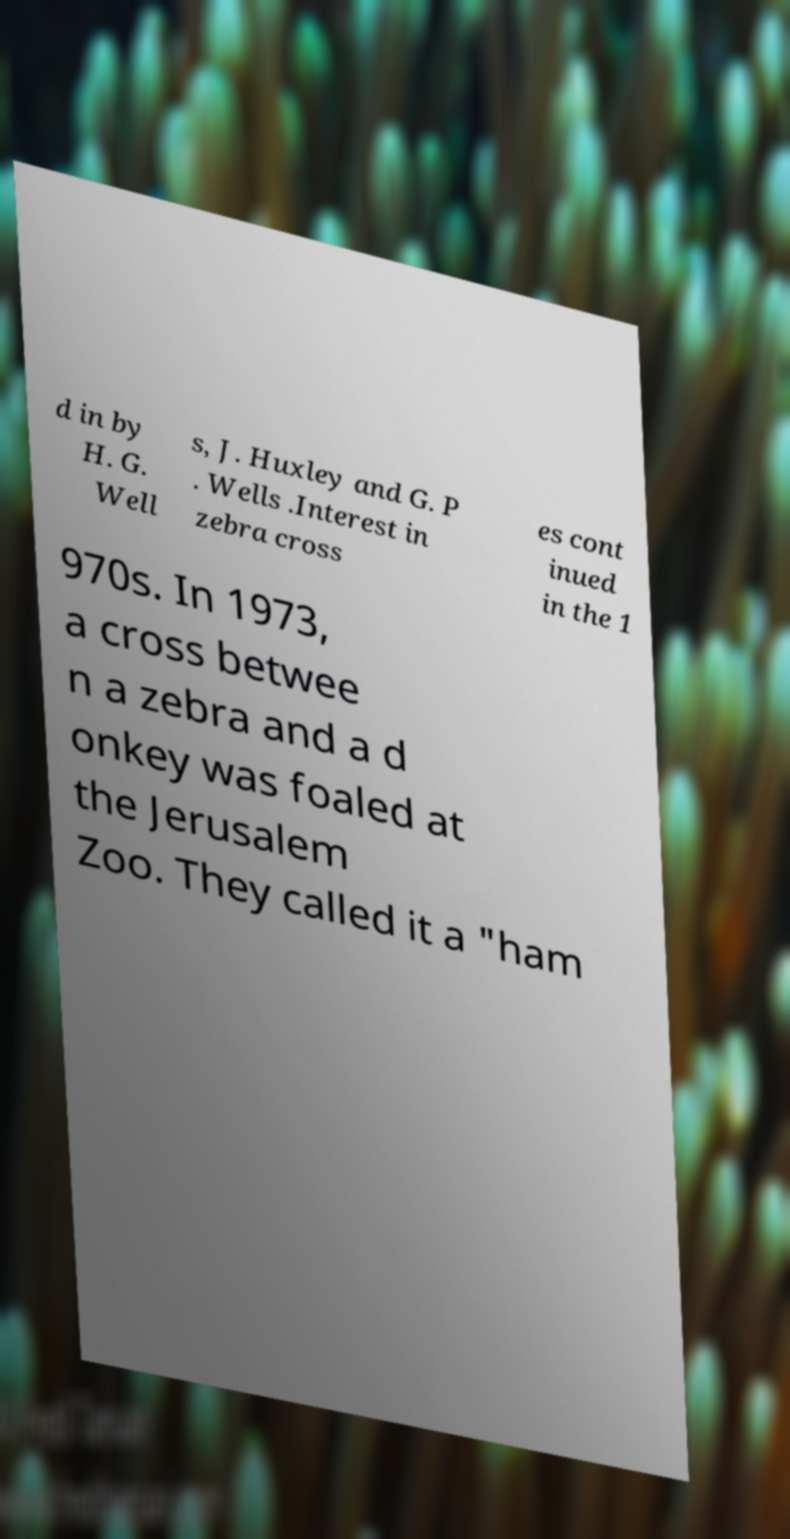There's text embedded in this image that I need extracted. Can you transcribe it verbatim? d in by H. G. Well s, J. Huxley and G. P . Wells .Interest in zebra cross es cont inued in the 1 970s. In 1973, a cross betwee n a zebra and a d onkey was foaled at the Jerusalem Zoo. They called it a "ham 